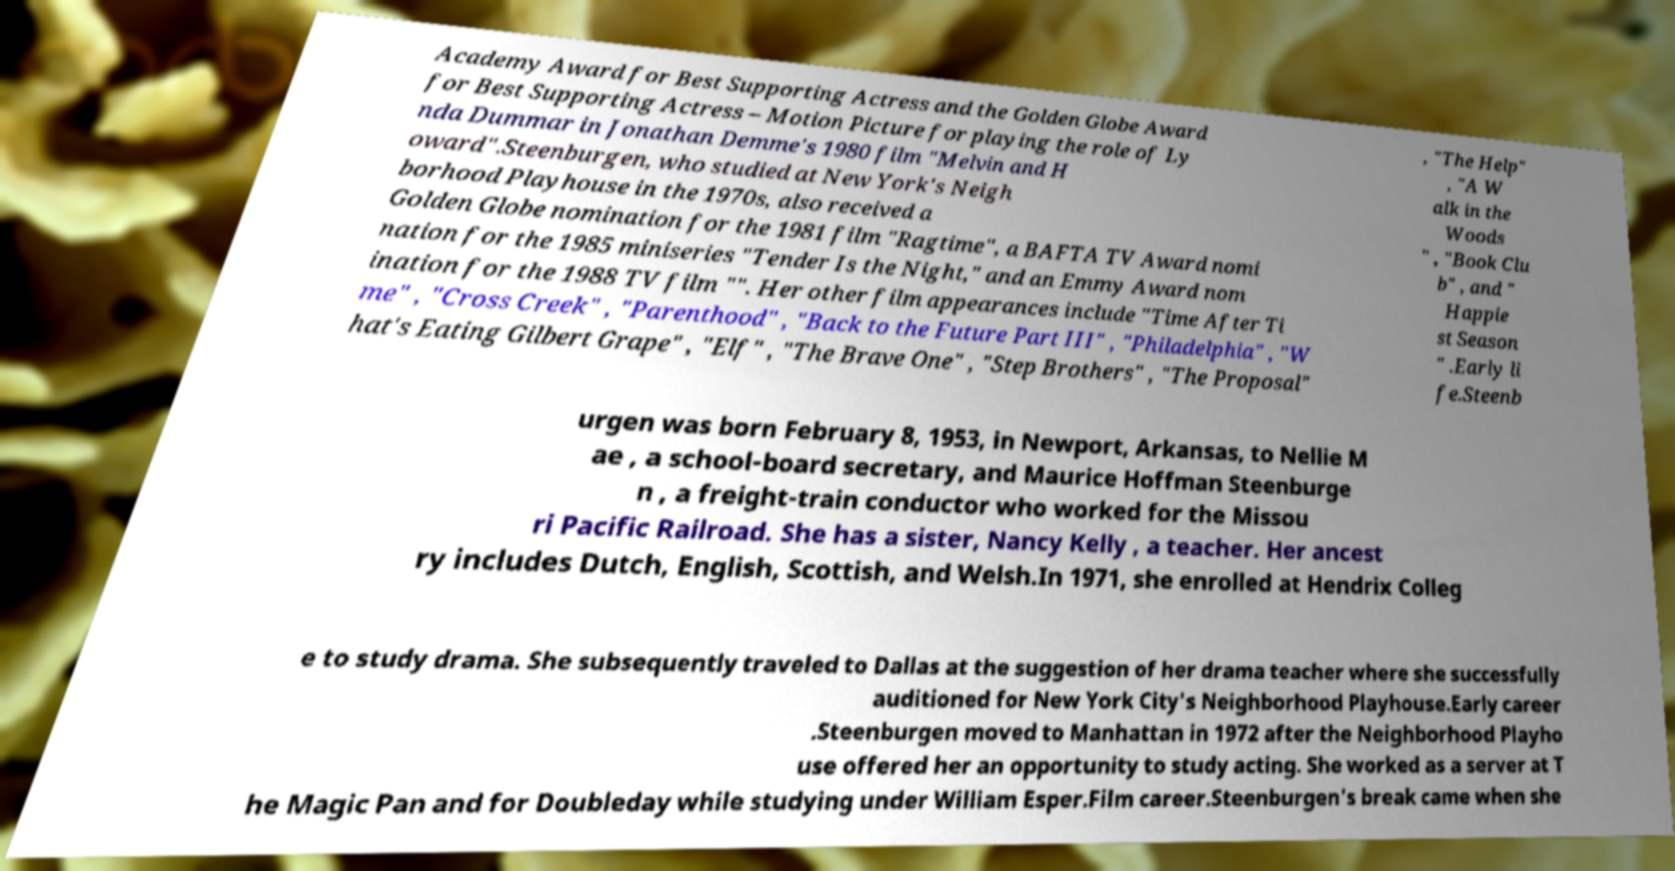Could you assist in decoding the text presented in this image and type it out clearly? Academy Award for Best Supporting Actress and the Golden Globe Award for Best Supporting Actress – Motion Picture for playing the role of Ly nda Dummar in Jonathan Demme's 1980 film "Melvin and H oward".Steenburgen, who studied at New York's Neigh borhood Playhouse in the 1970s, also received a Golden Globe nomination for the 1981 film "Ragtime", a BAFTA TV Award nomi nation for the 1985 miniseries "Tender Is the Night," and an Emmy Award nom ination for the 1988 TV film "". Her other film appearances include "Time After Ti me" , "Cross Creek" , "Parenthood" , "Back to the Future Part III" , "Philadelphia" , "W hat's Eating Gilbert Grape" , "Elf" , "The Brave One" , "Step Brothers" , "The Proposal" , "The Help" , "A W alk in the Woods " , "Book Clu b" , and " Happie st Season " .Early li fe.Steenb urgen was born February 8, 1953, in Newport, Arkansas, to Nellie M ae , a school-board secretary, and Maurice Hoffman Steenburge n , a freight-train conductor who worked for the Missou ri Pacific Railroad. She has a sister, Nancy Kelly , a teacher. Her ancest ry includes Dutch, English, Scottish, and Welsh.In 1971, she enrolled at Hendrix Colleg e to study drama. She subsequently traveled to Dallas at the suggestion of her drama teacher where she successfully auditioned for New York City's Neighborhood Playhouse.Early career .Steenburgen moved to Manhattan in 1972 after the Neighborhood Playho use offered her an opportunity to study acting. She worked as a server at T he Magic Pan and for Doubleday while studying under William Esper.Film career.Steenburgen's break came when she 